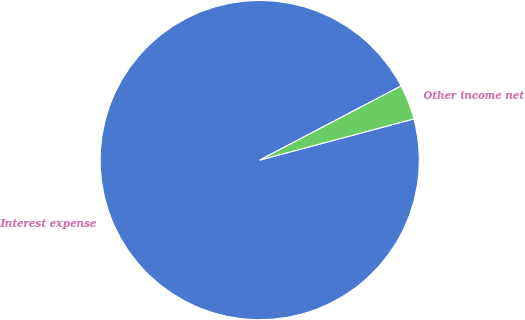Convert chart to OTSL. <chart><loc_0><loc_0><loc_500><loc_500><pie_chart><fcel>Interest expense<fcel>Other income net<nl><fcel>96.47%<fcel>3.53%<nl></chart> 